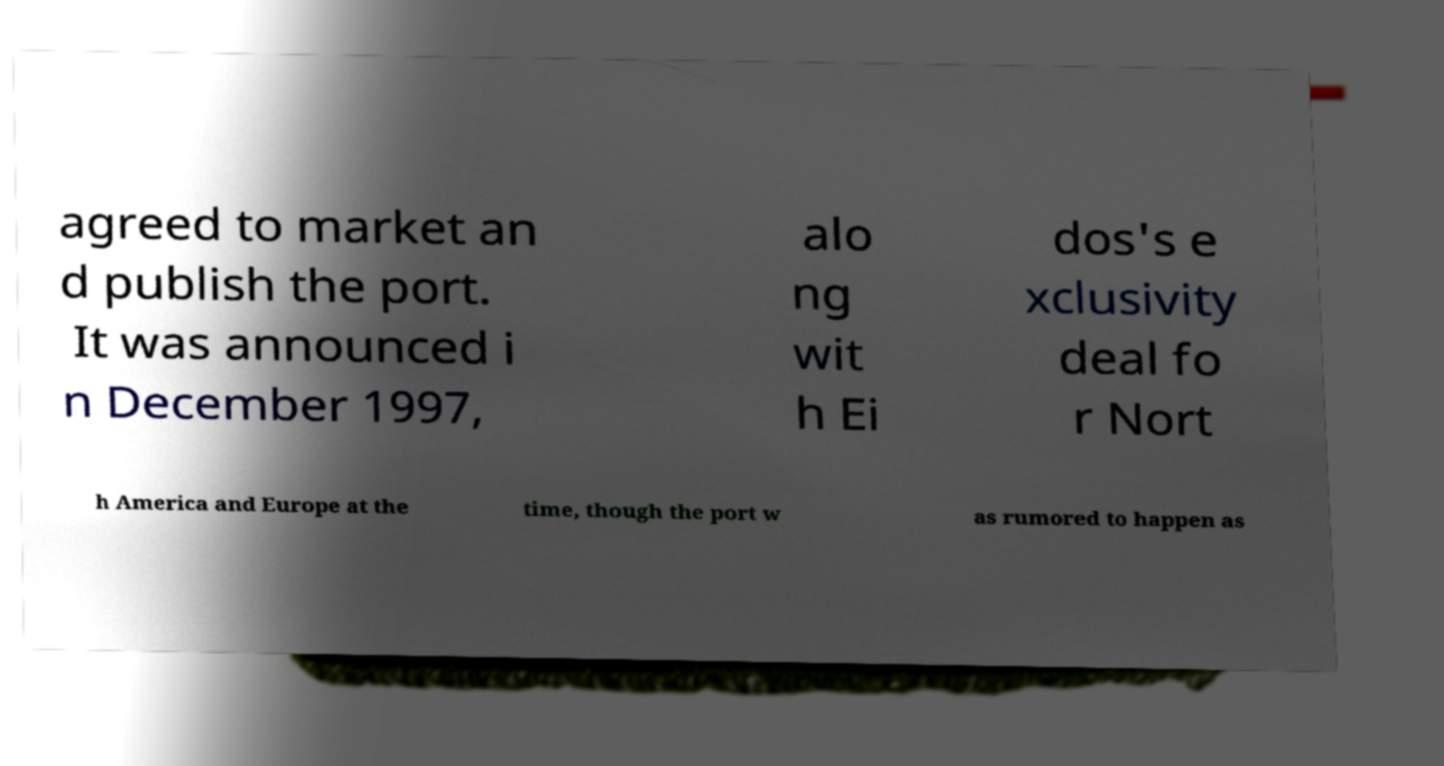Could you assist in decoding the text presented in this image and type it out clearly? agreed to market an d publish the port. It was announced i n December 1997, alo ng wit h Ei dos's e xclusivity deal fo r Nort h America and Europe at the time, though the port w as rumored to happen as 